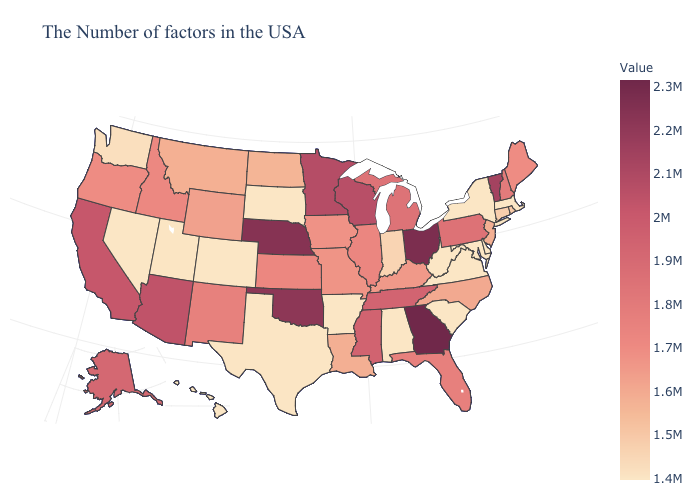Which states have the highest value in the USA?
Short answer required. Georgia. Does Florida have a higher value than Mississippi?
Write a very short answer. No. Which states hav the highest value in the Northeast?
Concise answer only. Vermont. Among the states that border Georgia , does Alabama have the highest value?
Keep it brief. No. Which states have the lowest value in the Northeast?
Keep it brief. Massachusetts, New York. Does Tennessee have a lower value than New Jersey?
Be succinct. No. Which states have the highest value in the USA?
Give a very brief answer. Georgia. Does Hawaii have the lowest value in the USA?
Concise answer only. Yes. 